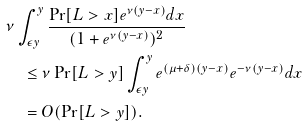Convert formula to latex. <formula><loc_0><loc_0><loc_500><loc_500>& \nu \int _ { \epsilon y } ^ { y } \frac { \Pr [ L > x ] e ^ { \nu ( y - x ) } d x } { ( 1 + e ^ { \nu ( y - x ) } ) ^ { 2 } } \\ & \quad \leq \nu \Pr [ L > y ] \int _ { \epsilon y } ^ { y } e ^ { ( \mu + \delta ) ( y - x ) } e ^ { - \nu ( y - x ) } d x \\ & \quad = O ( \Pr [ L > y ] ) .</formula> 